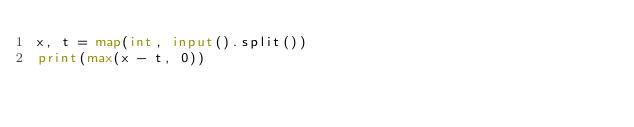<code> <loc_0><loc_0><loc_500><loc_500><_Python_>x, t = map(int, input().split())
print(max(x - t, 0))
</code> 